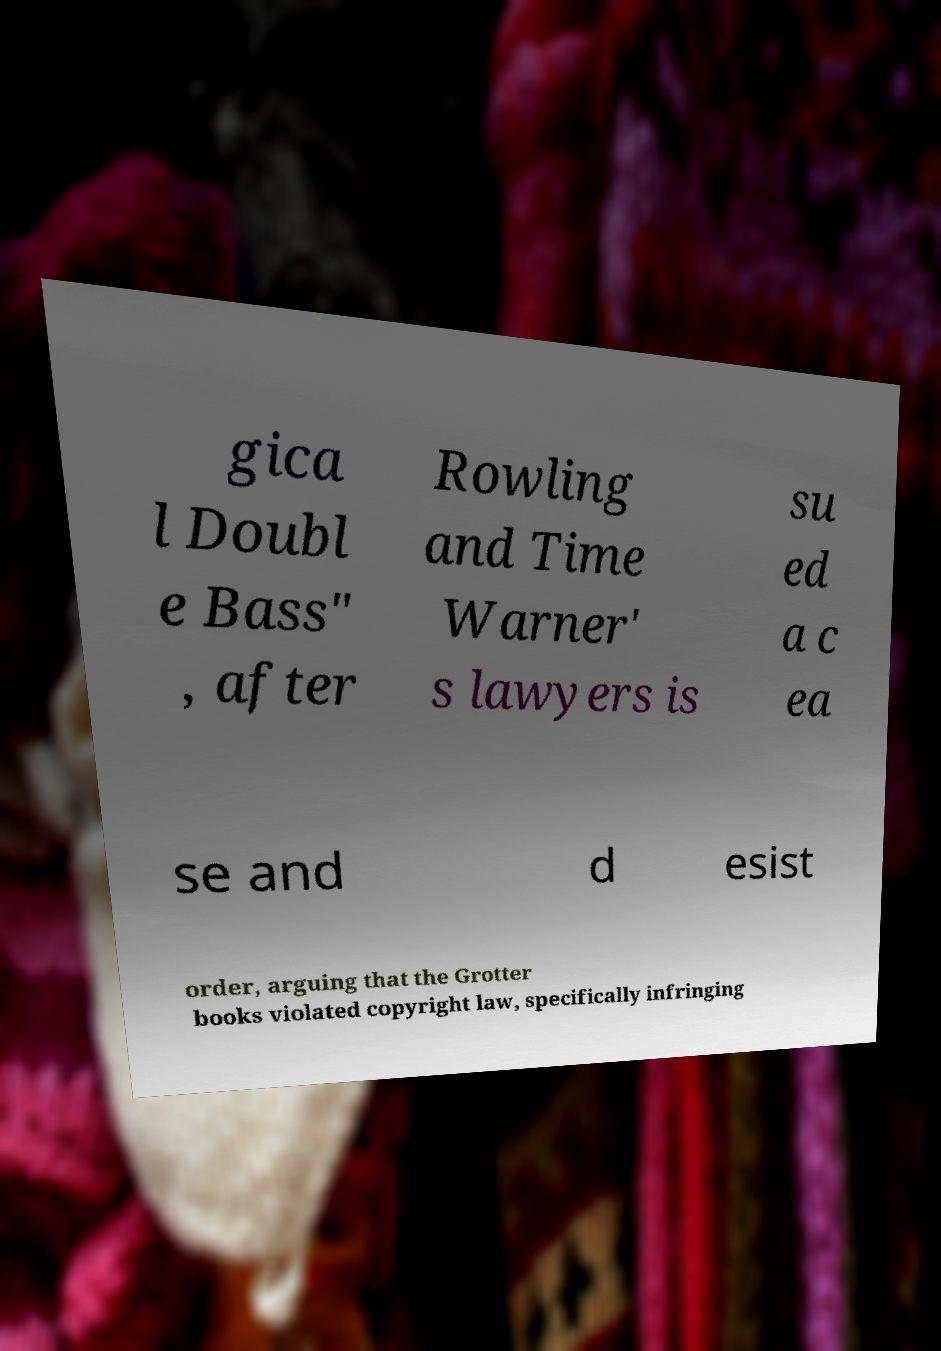Please identify and transcribe the text found in this image. gica l Doubl e Bass" , after Rowling and Time Warner' s lawyers is su ed a c ea se and d esist order, arguing that the Grotter books violated copyright law, specifically infringing 